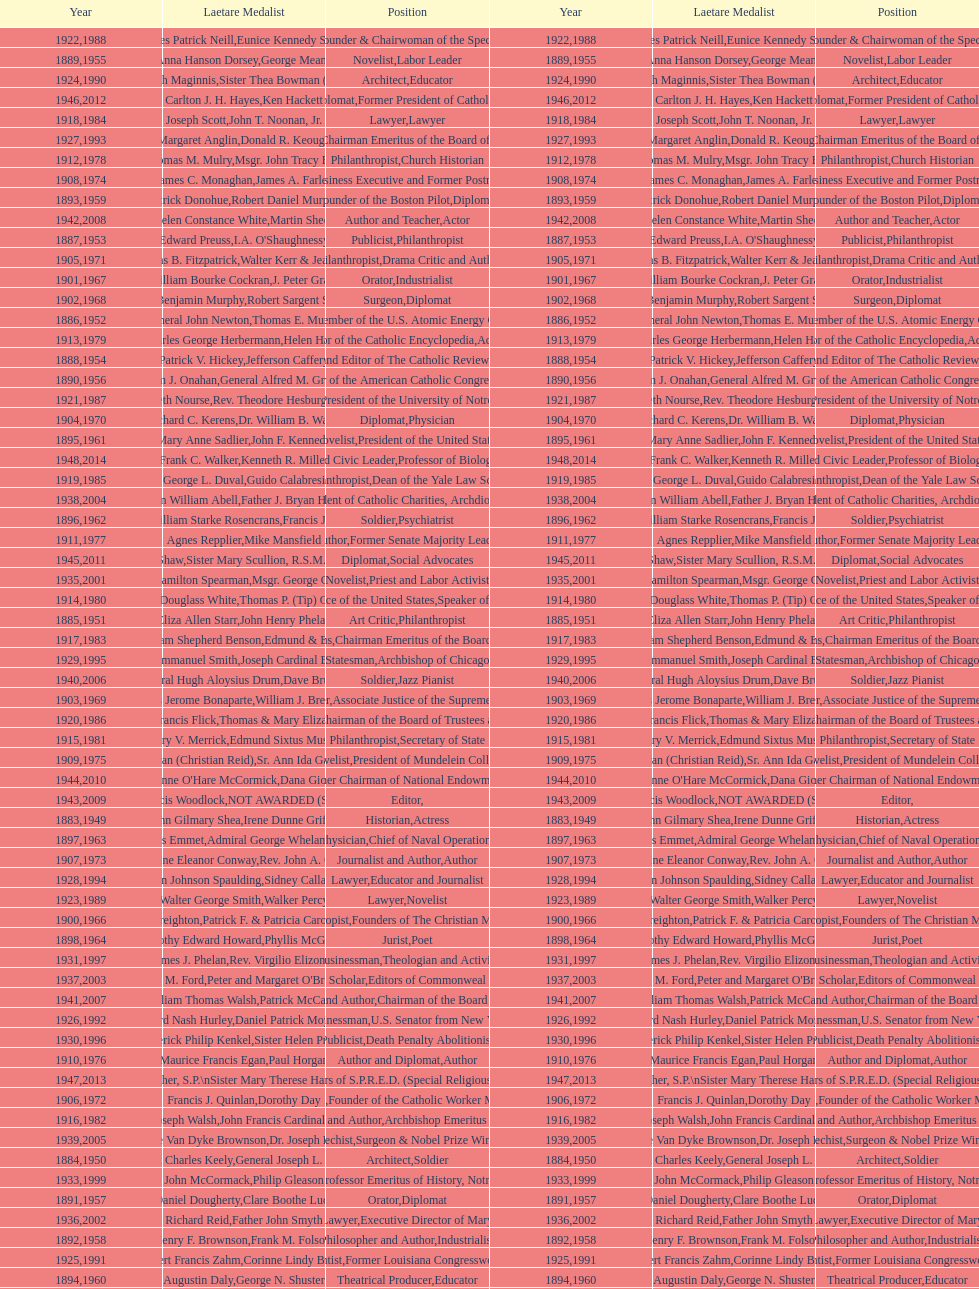Could you help me parse every detail presented in this table? {'header': ['Year', 'Laetare Medalist', 'Position', 'Year', 'Laetare Medalist', 'Position'], 'rows': [['1922', 'Charles Patrick Neill', 'Economist', '1988', 'Eunice Kennedy Shriver', 'Founder & Chairwoman of the Special Olympics'], ['1889', 'Anna Hanson Dorsey', 'Novelist', '1955', 'George Meany', 'Labor Leader'], ['1924', 'Charles Donagh Maginnis', 'Architect', '1990', 'Sister Thea Bowman (posthumously)', 'Educator'], ['1946', 'Carlton J. H. Hayes', 'Historian and Diplomat', '2012', 'Ken Hackett', 'Former President of Catholic Relief Services'], ['1918', 'Joseph Scott', 'Lawyer', '1984', 'John T. Noonan, Jr.', 'Lawyer'], ['1927', 'Margaret Anglin', 'Actress', '1993', 'Donald R. Keough', 'Chairman Emeritus of the Board of Trustees'], ['1912', 'Thomas M. Mulry', 'Philanthropist', '1978', 'Msgr. John Tracy Ellis', 'Church Historian'], ['1908', 'James C. Monaghan', 'Economist', '1974', 'James A. Farley', 'Business Executive and Former Postmaster General'], ['1893', 'Patrick Donohue', 'Founder of the Boston Pilot', '1959', 'Robert Daniel Murphy', 'Diplomat'], ['1942', 'Helen Constance White', 'Author and Teacher', '2008', 'Martin Sheen', 'Actor'], ['1887', 'Edward Preuss', 'Publicist', '1953', "I.A. O'Shaughnessy", 'Philanthropist'], ['1905', 'Thomas B. Fitzpatrick', 'Philanthropist', '1971', 'Walter Kerr & Jean Kerr', 'Drama Critic and Author'], ['1901', 'William Bourke Cockran', 'Orator', '1967', 'J. Peter Grace', 'Industrialist'], ['1902', 'John Benjamin Murphy', 'Surgeon', '1968', 'Robert Sargent Shriver', 'Diplomat'], ['1886', 'General John Newton', 'Engineer', '1952', 'Thomas E. Murray', 'Member of the U.S. Atomic Energy Commission'], ['1913', 'Charles George Herbermann', 'Editor of the Catholic Encyclopedia', '1979', 'Helen Hayes', 'Actress'], ['1888', 'Patrick V. Hickey', 'Founder and Editor of The Catholic Review', '1954', 'Jefferson Caffery', 'Diplomat'], ['1890', 'William J. Onahan', 'Organizer of the American Catholic Congress', '1956', 'General Alfred M. Gruenther', 'Soldier'], ['1921', 'Elizabeth Nourse', 'Artist', '1987', 'Rev. Theodore Hesburgh, CSC', 'President of the University of Notre Dame'], ['1904', 'Richard C. Kerens', 'Diplomat', '1970', 'Dr. William B. Walsh', 'Physician'], ['1895', 'Mary Anne Sadlier', 'Novelist', '1961', 'John F. Kennedy', 'President of the United States'], ['1948', 'Frank C. Walker', 'Postmaster General and Civic Leader', '2014', 'Kenneth R. Miller', 'Professor of Biology at Brown University'], ['1919', 'George L. Duval', 'Philanthropist', '1985', 'Guido Calabresi', 'Dean of the Yale Law School'], ['1938', 'Irvin William Abell', 'Surgeon', '2004', 'Father J. Bryan Hehir', 'President of Catholic Charities, Archdiocese of Boston'], ['1896', 'General William Starke Rosencrans', 'Soldier', '1962', 'Francis J. Braceland', 'Psychiatrist'], ['1911', 'Agnes Repplier', 'Author', '1977', 'Mike Mansfield', 'Former Senate Majority Leader'], ['1945', 'Gardiner Howland Shaw', 'Diplomat', '2011', 'Sister Mary Scullion, R.S.M., & Joan McConnon', 'Social Advocates'], ['1935', 'Francis Hamilton Spearman', 'Novelist', '2001', 'Msgr. George G. Higgins', 'Priest and Labor Activist'], ['1914', 'Edward Douglass White', 'Chief Justice of the United States', '1980', "Thomas P. (Tip) O'Neill Jr.", 'Speaker of the House'], ['1885', 'Eliza Allen Starr', 'Art Critic', '1951', 'John Henry Phelan', 'Philanthropist'], ['1917', 'Admiral William Shepherd Benson', 'Chief of Naval Operations', '1983', 'Edmund & Evelyn Stephan', 'Chairman Emeritus of the Board of Trustees and his wife'], ['1929', 'Alfred Emmanuel Smith', 'Statesman', '1995', 'Joseph Cardinal Bernardin', 'Archbishop of Chicago'], ['1940', 'General Hugh Aloysius Drum', 'Soldier', '2006', 'Dave Brubeck', 'Jazz Pianist'], ['1903', 'Charles Jerome Bonaparte', 'Lawyer', '1969', 'William J. Brennan Jr.', 'Associate Justice of the Supreme Court'], ['1920', 'Lawrence Francis Flick', 'Physician', '1986', 'Thomas & Mary Elizabeth Carney', 'Chairman of the Board of Trustees and his wife'], ['1915', 'Mary V. Merrick', 'Philanthropist', '1981', 'Edmund Sixtus Muskie', 'Secretary of State'], ['1909', 'Frances Tieran (Christian Reid)', 'Novelist', '1975', 'Sr. Ann Ida Gannon, BMV', 'President of Mundelein College'], ['1944', "Anne O'Hare McCormick", 'Journalist', '2010', 'Dana Gioia', 'Former Chairman of National Endowment for the Arts'], ['1943', 'Thomas Francis Woodlock', 'Editor', '2009', 'NOT AWARDED (SEE BELOW)', ''], ['1883', 'John Gilmary Shea', 'Historian', '1949', 'Irene Dunne Griffin', 'Actress'], ['1897', 'Thomas Addis Emmet', 'Physician', '1963', 'Admiral George Whelan Anderson, Jr.', 'Chief of Naval Operations'], ['1907', 'Katherine Eleanor Conway', 'Journalist and Author', '1973', "Rev. John A. O'Brien", 'Author'], ['1928', 'John Johnson Spaulding', 'Lawyer', '1994', 'Sidney Callahan', 'Educator and Journalist'], ['1923', 'Walter George Smith', 'Lawyer', '1989', 'Walker Percy', 'Novelist'], ['1900', 'John A. Creighton', 'Philanthropist', '1966', 'Patrick F. & Patricia Caron Crowley', 'Founders of The Christian Movement'], ['1898', 'Timothy Edward Howard', 'Jurist', '1964', 'Phyllis McGinley', 'Poet'], ['1931', 'James J. Phelan', 'Businessman', '1997', 'Rev. Virgilio Elizondo', 'Theologian and Activist'], ['1937', 'Jeremiah D. M. Ford', 'Scholar', '2003', "Peter and Margaret O'Brien Steinfels", 'Editors of Commonweal'], ['1941', 'William Thomas Walsh', 'Journalist and Author', '2007', 'Patrick McCartan', 'Chairman of the Board of Trustees'], ['1926', 'Edward Nash Hurley', 'Businessman', '1992', 'Daniel Patrick Moynihan', 'U.S. Senator from New York'], ['1930', 'Frederick Philip Kenkel', 'Publicist', '1996', 'Sister Helen Prejean', 'Death Penalty Abolitionist'], ['1910', 'Maurice Francis Egan', 'Author and Diplomat', '1976', 'Paul Horgan', 'Author'], ['1947', 'William G. Bruce', 'Publisher and Civic Leader', '2013', 'Sister Susanne Gallagher, S.P.\\nSister Mary Therese Harrington, S.H.\\nRev. James H. McCarthy', 'Founders of S.P.R.E.D. (Special Religious Education Development Network)'], ['1906', 'Francis J. Quinlan', 'Physician', '1972', 'Dorothy Day', 'Founder of the Catholic Worker Movement'], ['1916', 'James Joseph Walsh', 'Physician and Author', '1982', 'John Francis Cardinal Dearden', 'Archbishop Emeritus of Detroit'], ['1939', 'Josephine Van Dyke Brownson', 'Catechist', '2005', 'Dr. Joseph E. Murray', 'Surgeon & Nobel Prize Winner'], ['1884', 'Patrick Charles Keely', 'Architect', '1950', 'General Joseph L. Collins', 'Soldier'], ['1933', 'John McCormack', 'Artist', '1999', 'Philip Gleason', 'Professor Emeritus of History, Notre Dame'], ['1891', 'Daniel Dougherty', 'Orator', '1957', 'Clare Boothe Luce', 'Diplomat'], ['1936', 'Richard Reid', 'Journalist and Lawyer', '2002', 'Father John Smyth', 'Executive Director of Maryville Academy'], ['1892', 'Henry F. Brownson', 'Philosopher and Author', '1958', 'Frank M. Folsom', 'Industrialist'], ['1925', 'Albert Francis Zahm', 'Scientist', '1991', 'Corinne Lindy Boggs', 'Former Louisiana Congresswoman'], ['1894', 'Augustin Daly', 'Theatrical Producer', '1960', 'George N. Shuster', 'Educator'], ['1932', 'Stephen J. Maher', 'Physician', '1998', 'Dr. Edmund D. Pellegrino', 'Medical Ethicist and Educator'], ['1934', 'Genevieve Garvan Brady', 'Philanthropist', '2000', 'Andrew McKenna', 'Chairman of the Board of Trustees'], ['1899', 'Mary Gwendolin Caldwell', 'Philanthropist', '1965', 'Frederick D. Rossini', 'Scientist']]} Who won the medal after thomas e. murray in 1952? I.A. O'Shaughnessy. 